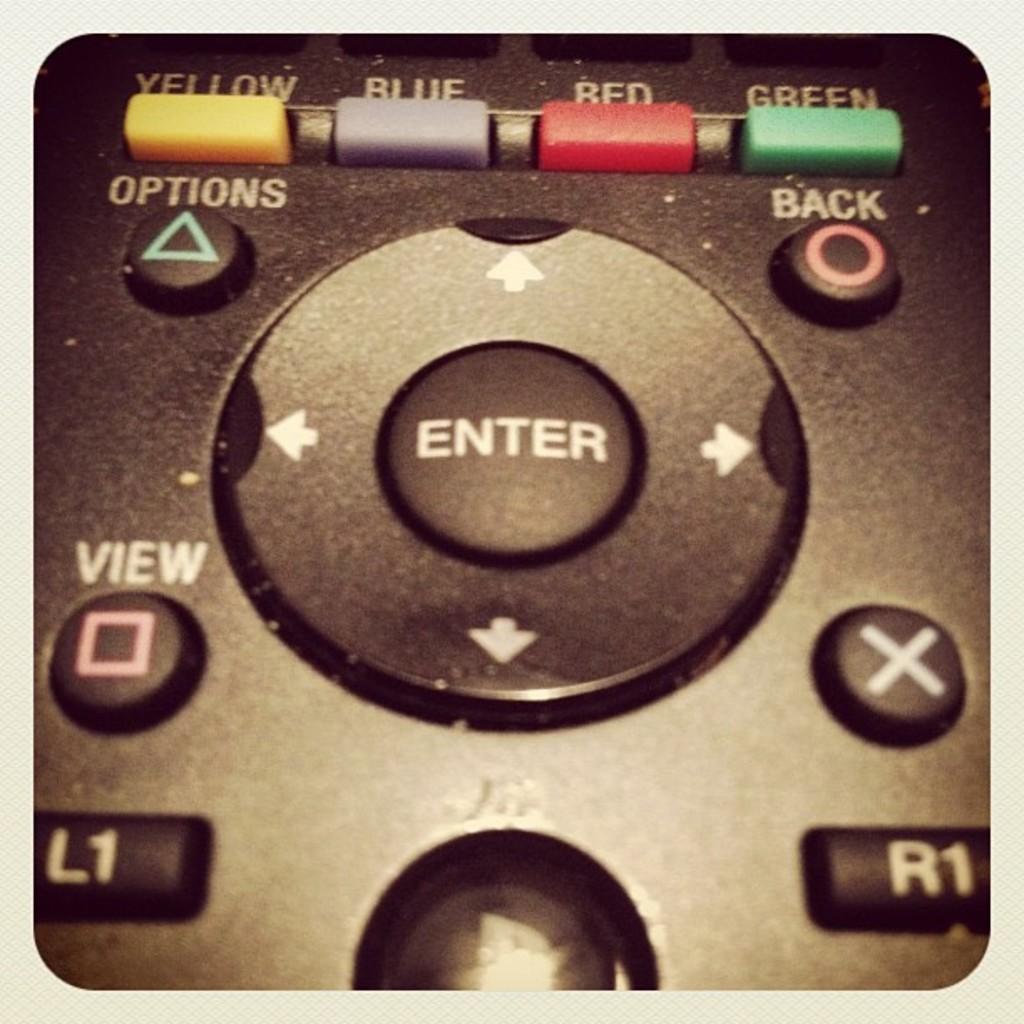What is the triangle button used for?
Your response must be concise. Options. What is the center button?
Offer a very short reply. Enter. 